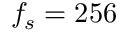Convert formula to latex. <formula><loc_0><loc_0><loc_500><loc_500>f _ { s } = 2 5 6</formula> 